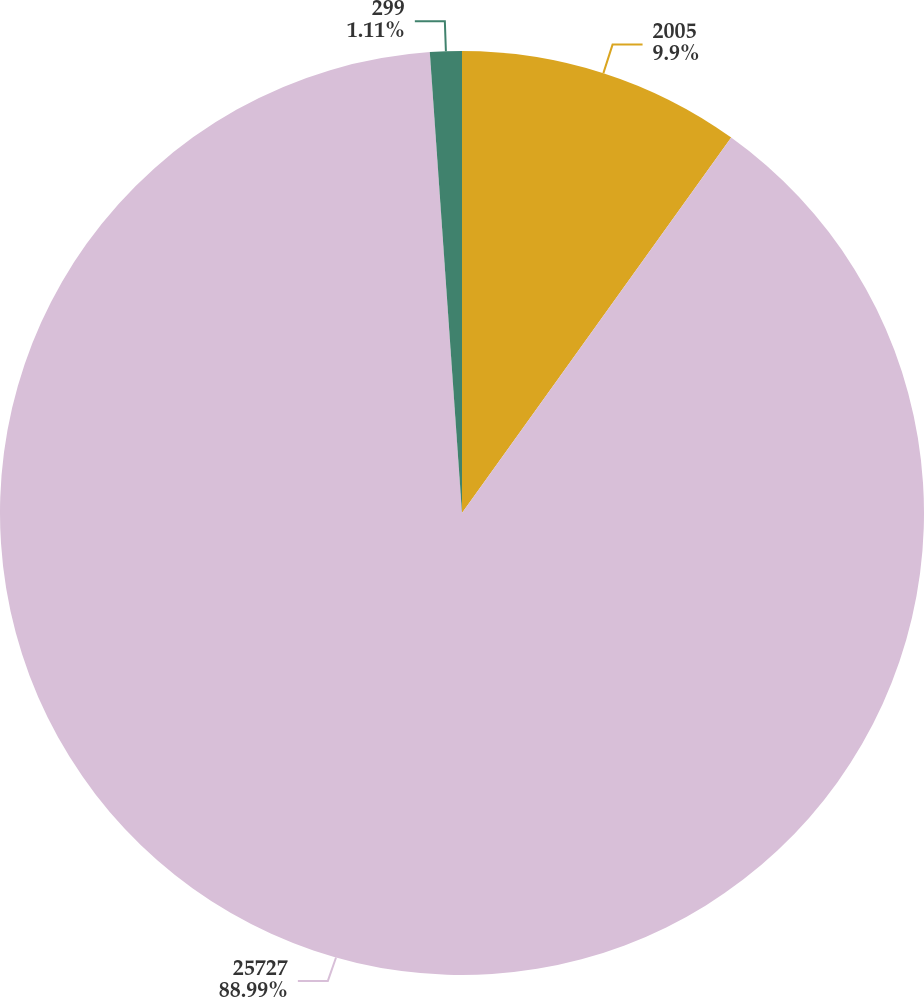Convert chart. <chart><loc_0><loc_0><loc_500><loc_500><pie_chart><fcel>2005<fcel>25727<fcel>299<nl><fcel>9.9%<fcel>88.99%<fcel>1.11%<nl></chart> 